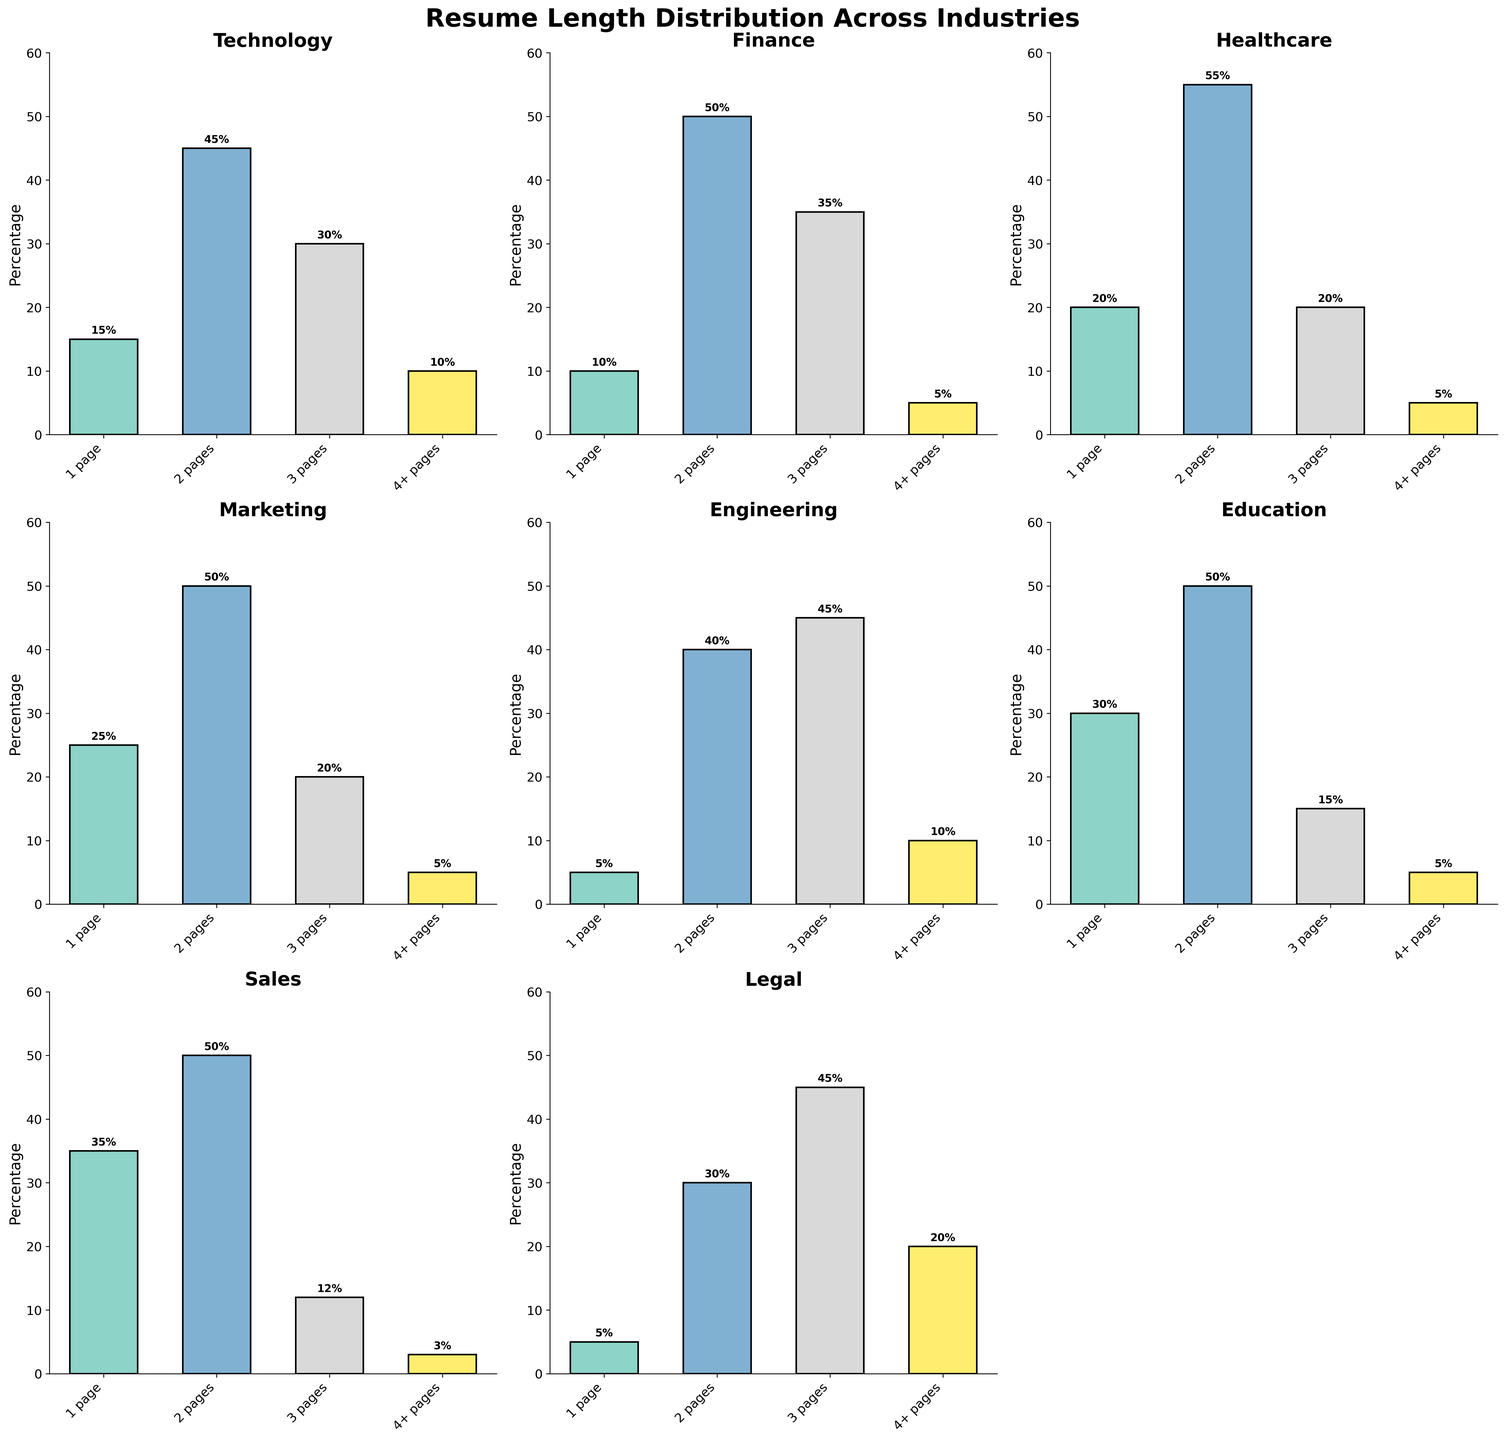What is the most common resume length in the Technology industry? First, identify the industry "Technology" on the subplot. Next, observe the heights of the bars representing different resume lengths. The tallest bar indicates the most common resume length. For Technology, the tallest bar corresponds to "2 pages".
Answer: 2 pages Which industry has the highest percentage of 1-page resumes? Identify the bars representing "1 page" resumes in each subplot. Compare their heights across all industries. The tallest bar in this category is found in the subplot for the "Sales" industry.
Answer: Sales Comparing the Healthcare and Finance industries, which one has a higher percentage of 3-page resumes? Look at the bars for "3 pages" resumes in both the Healthcare and Finance subplots. Healthcare has a 20% bar, whereas Finance has a 35% bar for 3-page resumes. Hence, Finance has a higher percentage.
Answer: Finance What is the sum of the percentages of 1-page and 4+ page resumes in the Education industry? Find the percentages of the "1 page" and "4+ pages" bars in the Education subplot. These are 30% and 5%, respectively. Add them up: 30% + 5% = 35%.
Answer: 35% How many industries have the most common resume length as "2 pages"? Check each subplot to find out which resume length has the highest percentage (tallest bar). Count the subplots where "2 pages" is the tallest. These industries are Technology, Finance, Healthcare, Marketing, Education, and Sales, making a total of 6.
Answer: 6 Which industry has the smallest percentage of 4+ page resumes? Identify the bars for "4+ pages" resumes across all subplots. The shortest bar represents the smallest percentage. In this case, the "Sales" industry has the shortest bar at 3%.
Answer: Sales For the Legal industry, what is the difference between the percentages of 2-page and 3-page resumes? Find the percentages of the "2 pages" bar and the "3 pages" bar in the Legal subplot. The values are 30% and 45%, respectively. Calculate the difference: 45% - 30% = 15%.
Answer: 15% In the Engineering industry, what percentage of resumes are either 2 pages or 3 pages? Find the percentages for "2 pages" and "3 pages" bars in the Engineering subplot. These are 40% and 45%, respectively. Add them up: 40% + 45% = 85%.
Answer: 85% Is there any industry where the percentage of 1-page resumes is higher than the percentage of 2-page resumes? Compare the bar heights for "1 page" and "2 pages" in each subplot. The "Sales" industry is the only one where the 1-page resumes (35%) are higher than the 2-page resumes (50%).
Answer: No Among the Technology, Finance, and Marketing industries, which has the highest percentage of 4+ page resumes? Analyze the bars for "4+ pages" resumes in the Technology, Finance, and Marketing subplots. They have percentages of 10%, 5%, and 5%, respectively. Technology has the highest at 10%.
Answer: Technology 